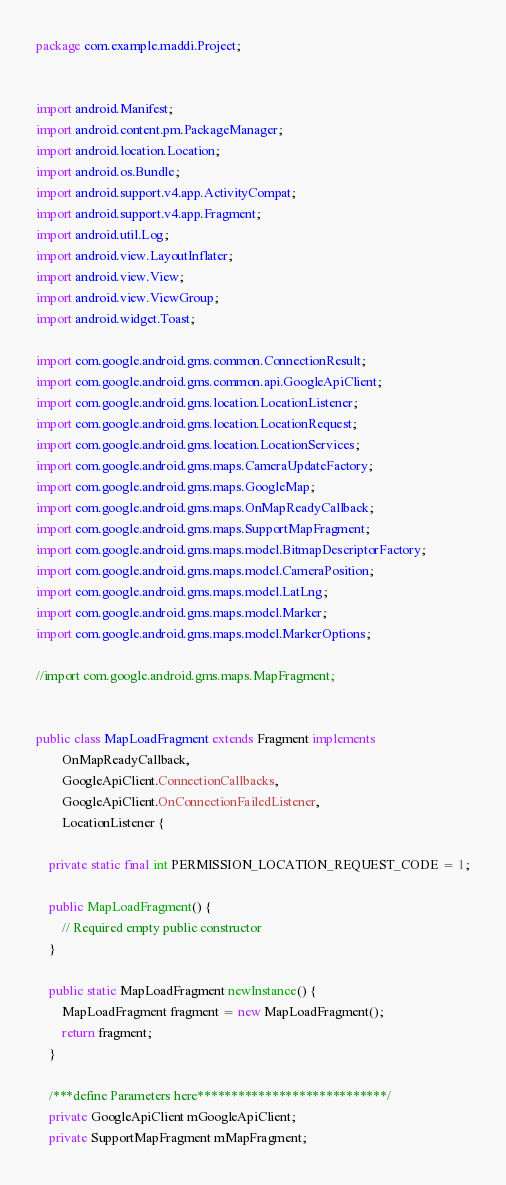<code> <loc_0><loc_0><loc_500><loc_500><_Java_>package com.example.maddi.Project;


import android.Manifest;
import android.content.pm.PackageManager;
import android.location.Location;
import android.os.Bundle;
import android.support.v4.app.ActivityCompat;
import android.support.v4.app.Fragment;
import android.util.Log;
import android.view.LayoutInflater;
import android.view.View;
import android.view.ViewGroup;
import android.widget.Toast;

import com.google.android.gms.common.ConnectionResult;
import com.google.android.gms.common.api.GoogleApiClient;
import com.google.android.gms.location.LocationListener;
import com.google.android.gms.location.LocationRequest;
import com.google.android.gms.location.LocationServices;
import com.google.android.gms.maps.CameraUpdateFactory;
import com.google.android.gms.maps.GoogleMap;
import com.google.android.gms.maps.OnMapReadyCallback;
import com.google.android.gms.maps.SupportMapFragment;
import com.google.android.gms.maps.model.BitmapDescriptorFactory;
import com.google.android.gms.maps.model.CameraPosition;
import com.google.android.gms.maps.model.LatLng;
import com.google.android.gms.maps.model.Marker;
import com.google.android.gms.maps.model.MarkerOptions;

//import com.google.android.gms.maps.MapFragment;


public class MapLoadFragment extends Fragment implements
        OnMapReadyCallback,
        GoogleApiClient.ConnectionCallbacks,
        GoogleApiClient.OnConnectionFailedListener,
        LocationListener {

    private static final int PERMISSION_LOCATION_REQUEST_CODE = 1;

    public MapLoadFragment() {
        // Required empty public constructor
    }

    public static MapLoadFragment newInstance() {
        MapLoadFragment fragment = new MapLoadFragment();
        return fragment;
    }

    /***define Parameters here****************************/
    private GoogleApiClient mGoogleApiClient;
    private SupportMapFragment mMapFragment;</code> 